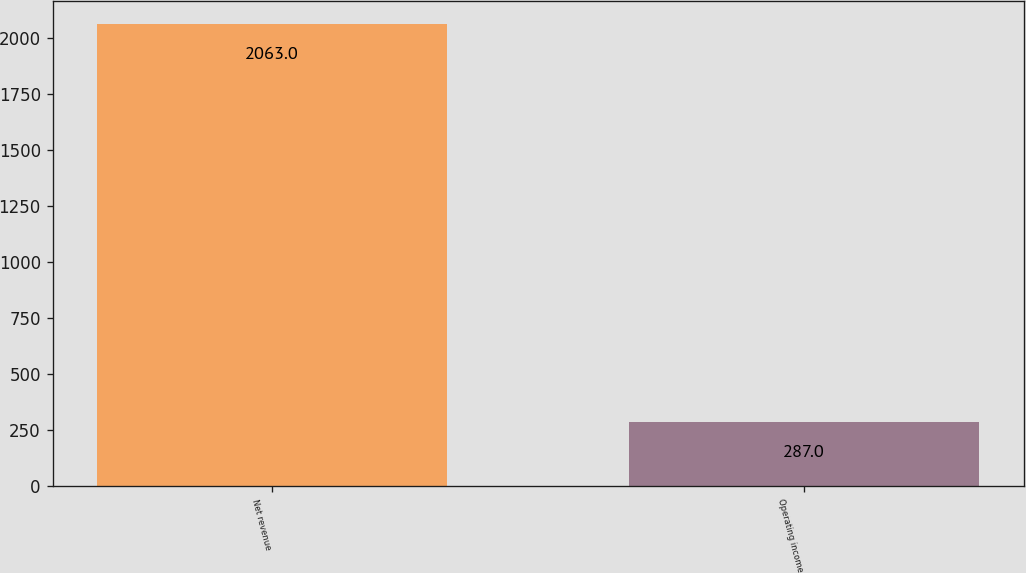<chart> <loc_0><loc_0><loc_500><loc_500><bar_chart><fcel>Net revenue<fcel>Operating income<nl><fcel>2063<fcel>287<nl></chart> 